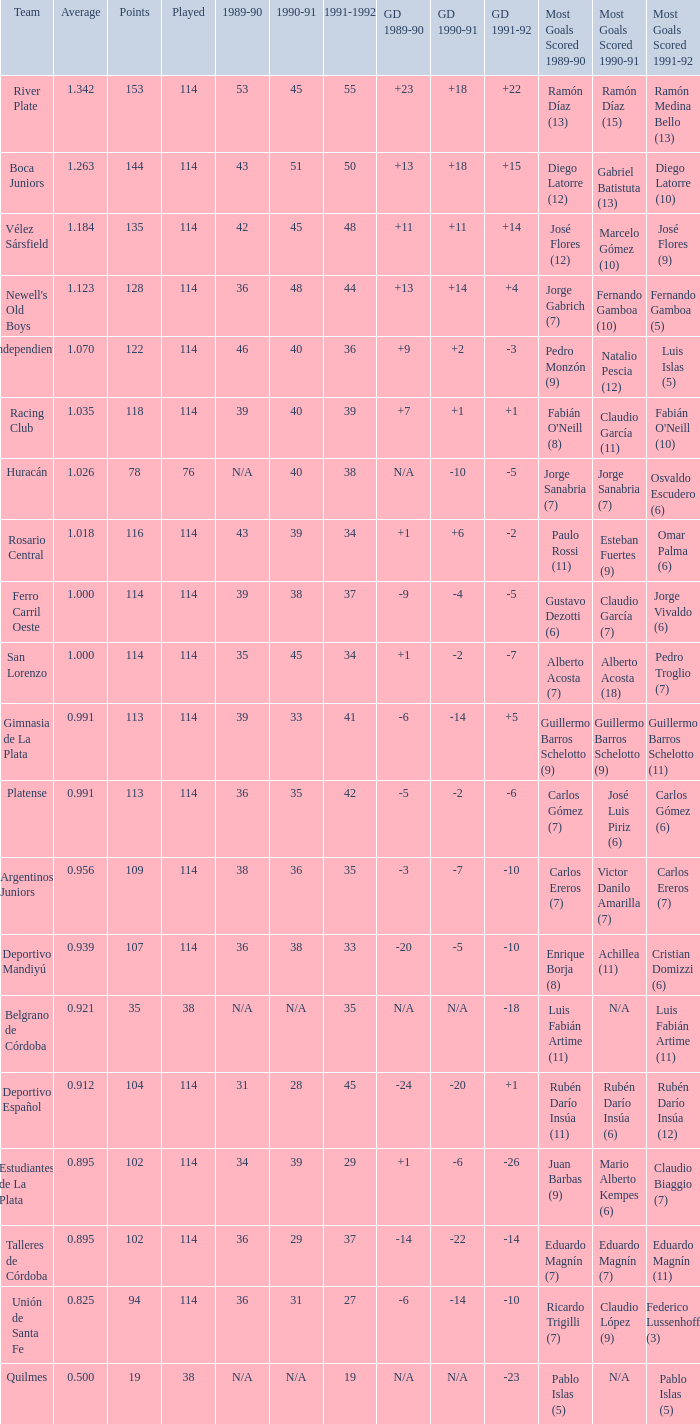How much 1991-1992 has a 1989-90 of 36, and an Average of 0.8250000000000001? 0.0. 